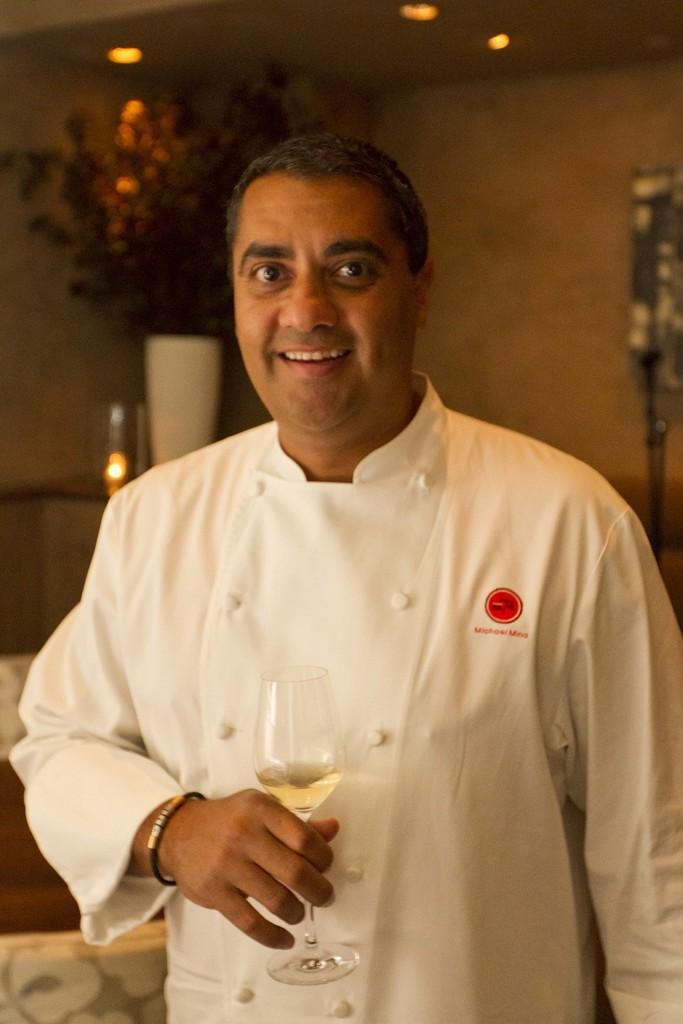What is the person in the image doing? The person in the image is holding a glass. What else can be seen in the image besides the person? There is a flower vase and lights in the background of the image, as well as a wall. What type of brake can be seen on the floor in the image? There is no brake present in the image; the floor is not visible in the provided facts. 